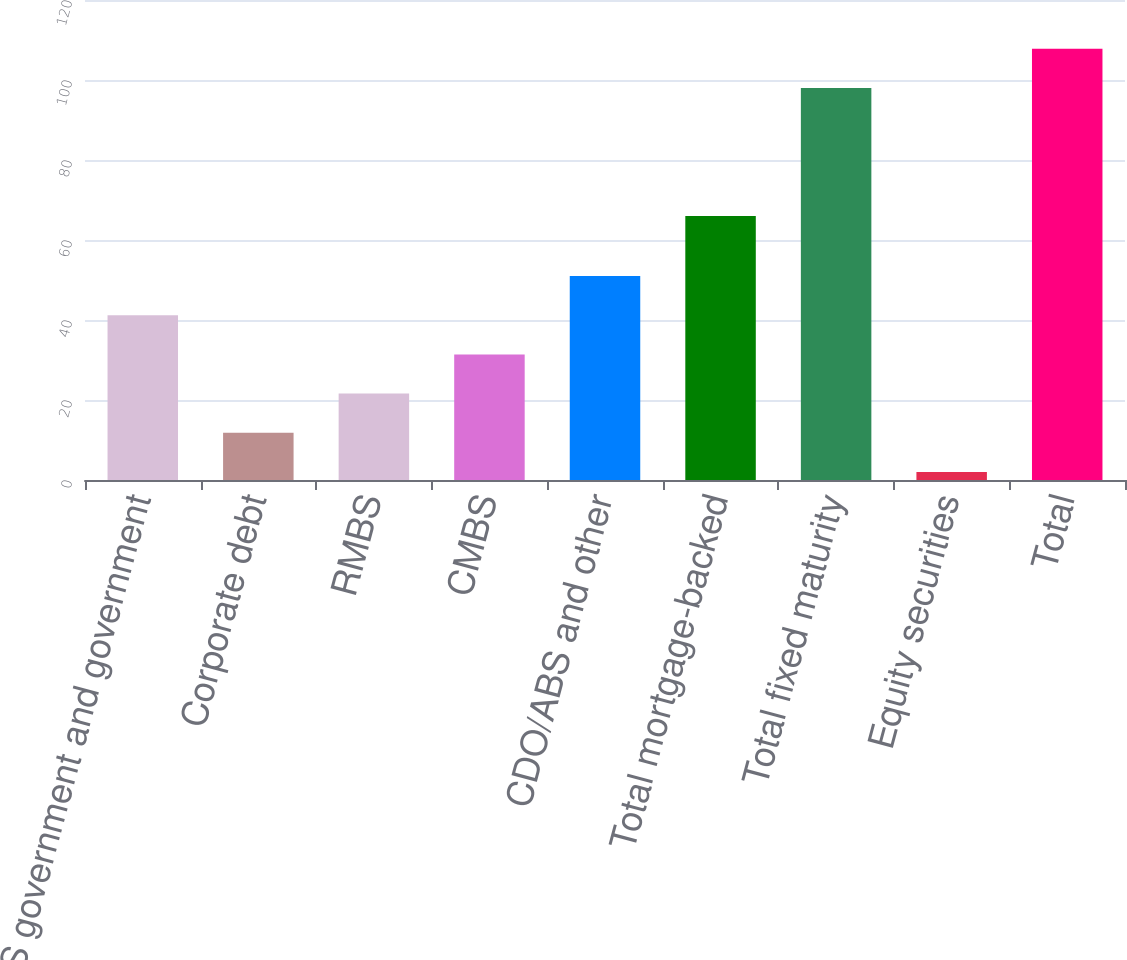Convert chart. <chart><loc_0><loc_0><loc_500><loc_500><bar_chart><fcel>US government and government<fcel>Corporate debt<fcel>RMBS<fcel>CMBS<fcel>CDO/ABS and other<fcel>Total mortgage-backed<fcel>Total fixed maturity<fcel>Equity securities<fcel>Total<nl><fcel>41.2<fcel>11.8<fcel>21.6<fcel>31.4<fcel>51<fcel>66<fcel>98<fcel>2<fcel>107.8<nl></chart> 